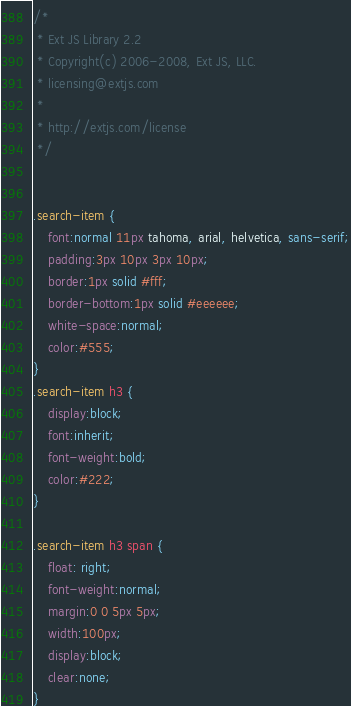Convert code to text. <code><loc_0><loc_0><loc_500><loc_500><_CSS_>/*
 * Ext JS Library 2.2
 * Copyright(c) 2006-2008, Ext JS, LLC.
 * licensing@extjs.com
 * 
 * http://extjs.com/license
 */


.search-item {
    font:normal 11px tahoma, arial, helvetica, sans-serif;
    padding:3px 10px 3px 10px;
    border:1px solid #fff;
    border-bottom:1px solid #eeeeee;
    white-space:normal;
    color:#555;
}
.search-item h3 {
    display:block;
    font:inherit;
    font-weight:bold;
    color:#222;
}

.search-item h3 span {
    float: right;
    font-weight:normal;
    margin:0 0 5px 5px;
    width:100px;
    display:block;
    clear:none;
}
</code> 